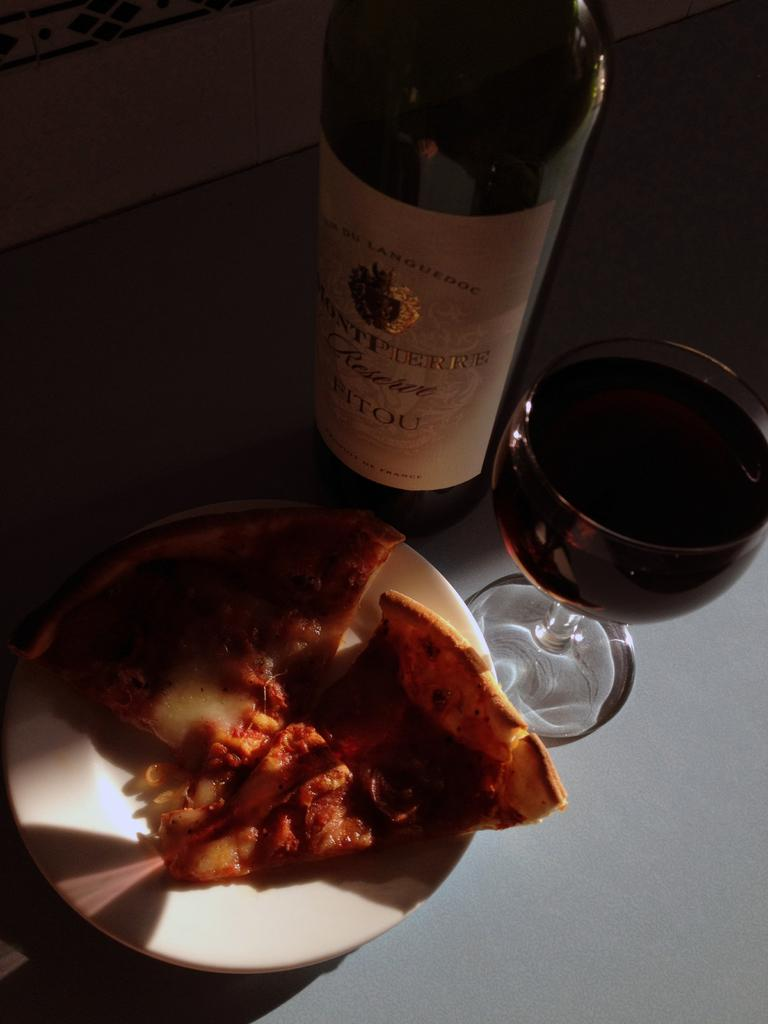<image>
Write a terse but informative summary of the picture. the word pierre is on the front of a bottle 